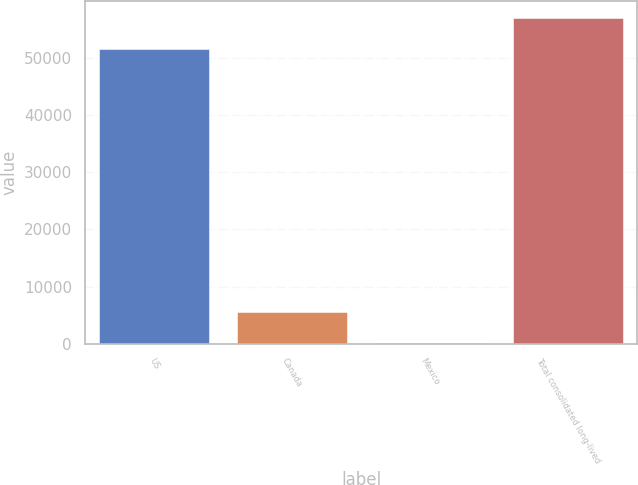Convert chart. <chart><loc_0><loc_0><loc_500><loc_500><bar_chart><fcel>US<fcel>Canada<fcel>Mexico<fcel>Total consolidated long-lived<nl><fcel>51679<fcel>5454.2<fcel>67<fcel>57066.2<nl></chart> 